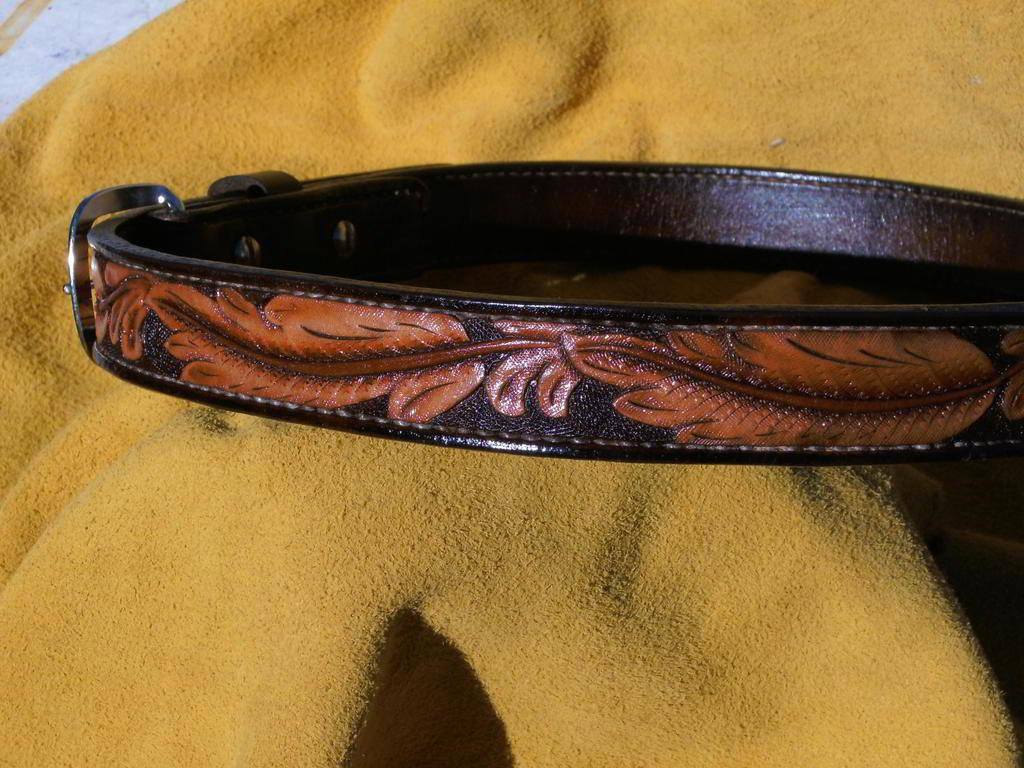What object can be seen in the image? There is a belt in the image. What can be observed about the belt's appearance? The belt has designs on it. What is the belt placed on in the image? The belt is placed on a yellow cloth. Can you tell me how many fish are swimming in the sea in the image? There is no sea or fish present in the image; it features a belt with designs on it, placed on a yellow cloth. 